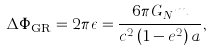<formula> <loc_0><loc_0><loc_500><loc_500>\Delta \Phi _ { \text {GR} } = 2 \pi \epsilon = \frac { 6 \pi G _ { N } m } { c ^ { 2 } \left ( 1 - e ^ { 2 } \right ) a } ,</formula> 